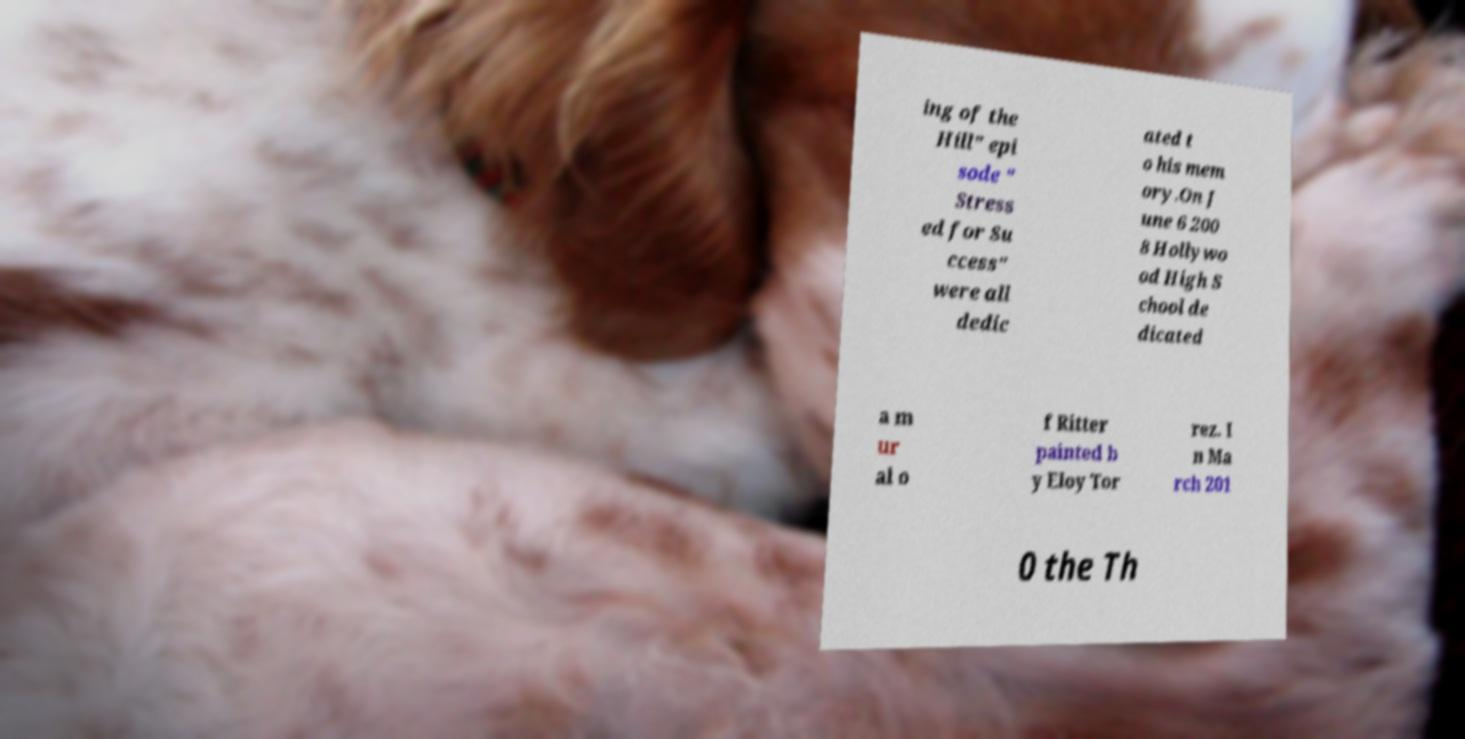Please identify and transcribe the text found in this image. ing of the Hill" epi sode " Stress ed for Su ccess" were all dedic ated t o his mem ory.On J une 6 200 8 Hollywo od High S chool de dicated a m ur al o f Ritter painted b y Eloy Tor rez. I n Ma rch 201 0 the Th 